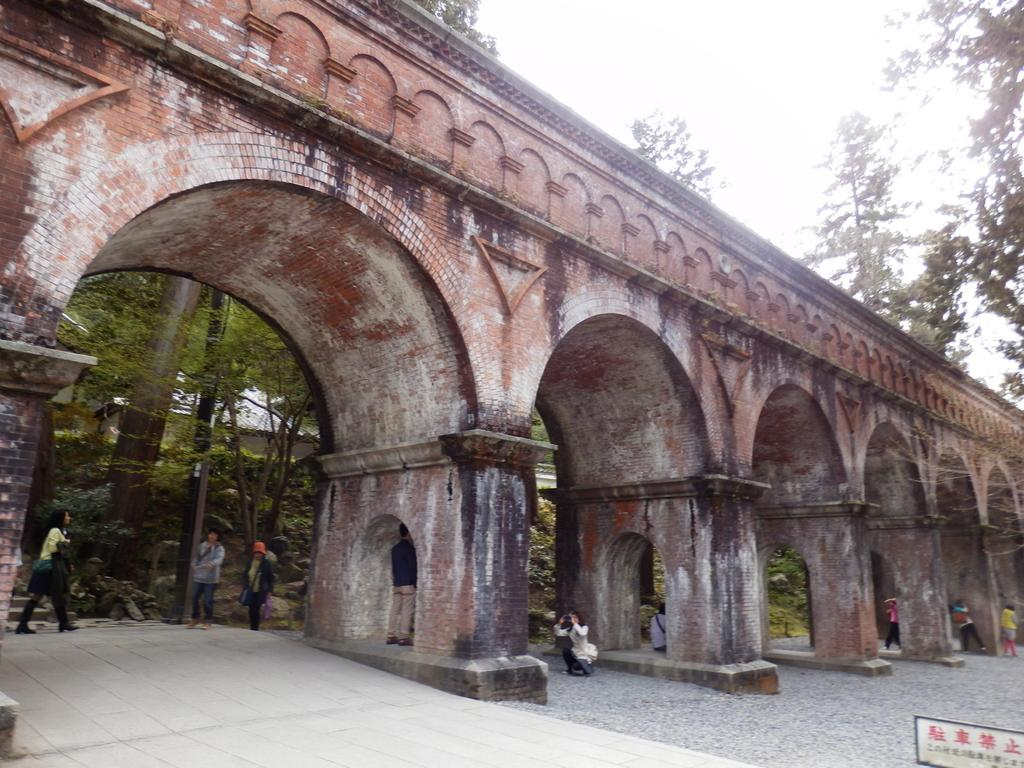What type of structure is in the image? There is a bridge with an arch in the image. Are there any people in the image? Yes, there are people in the image. What other objects can be seen in the image? There is a board and a pole in the image. What type of natural elements are present in the image? There are trees in the image. What can be seen in the background of the image? The sky is visible in the background of the image. What type of clam is being used as a can on the board in the image? There is no clam or can present on the board in the image. Is there a notebook visible in the image? There is no notebook visible in the image. 